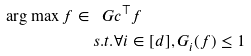<formula> <loc_0><loc_0><loc_500><loc_500>\arg \max { f \in \ G } & c ^ { \top } f \\ s . t . & \forall i \in [ d ] , G _ { i } ( f ) \leq 1</formula> 